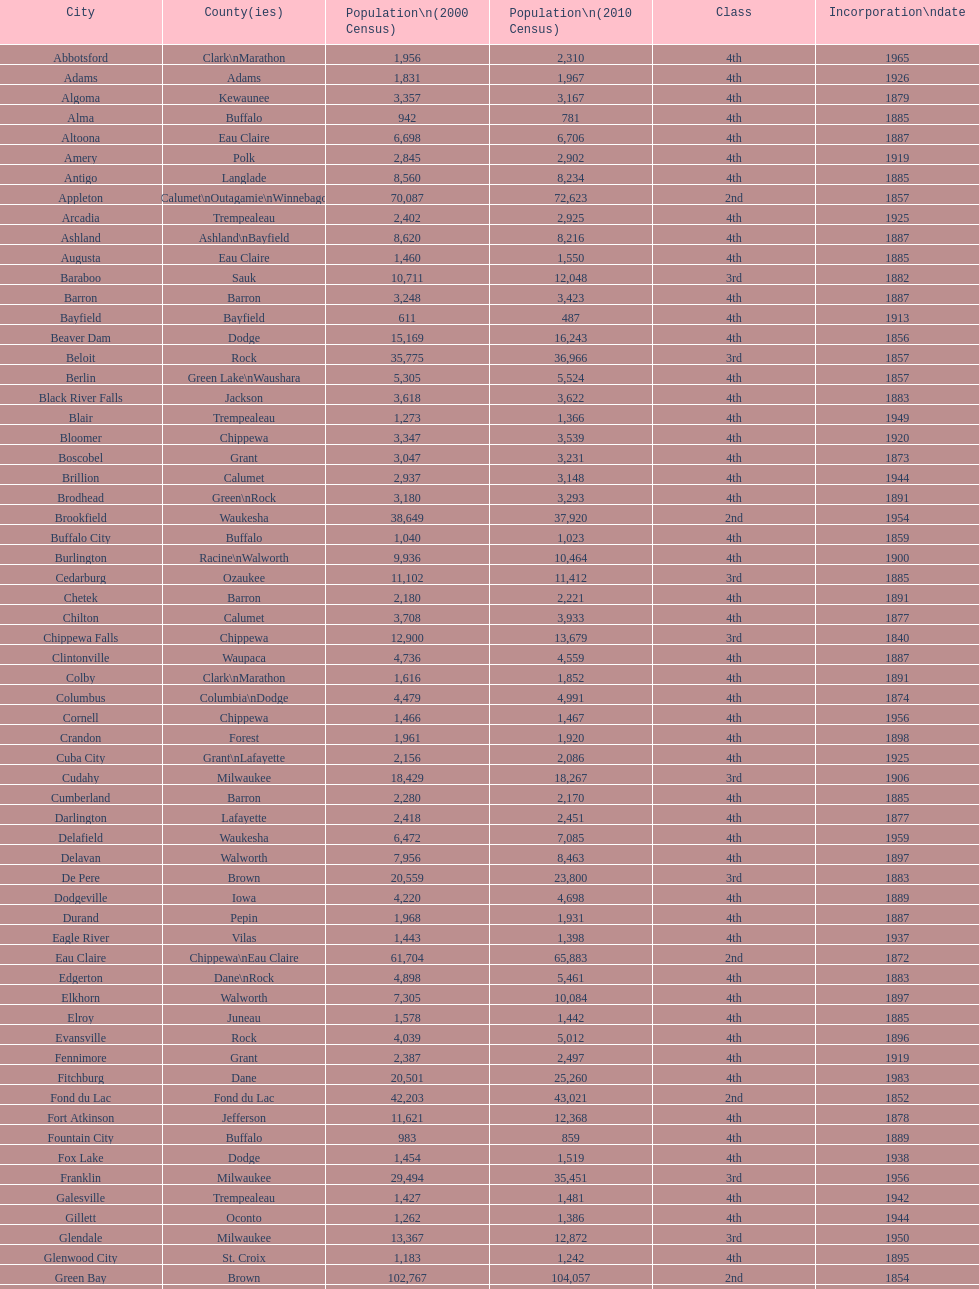Which city has the most population in the 2010 census? Milwaukee. 